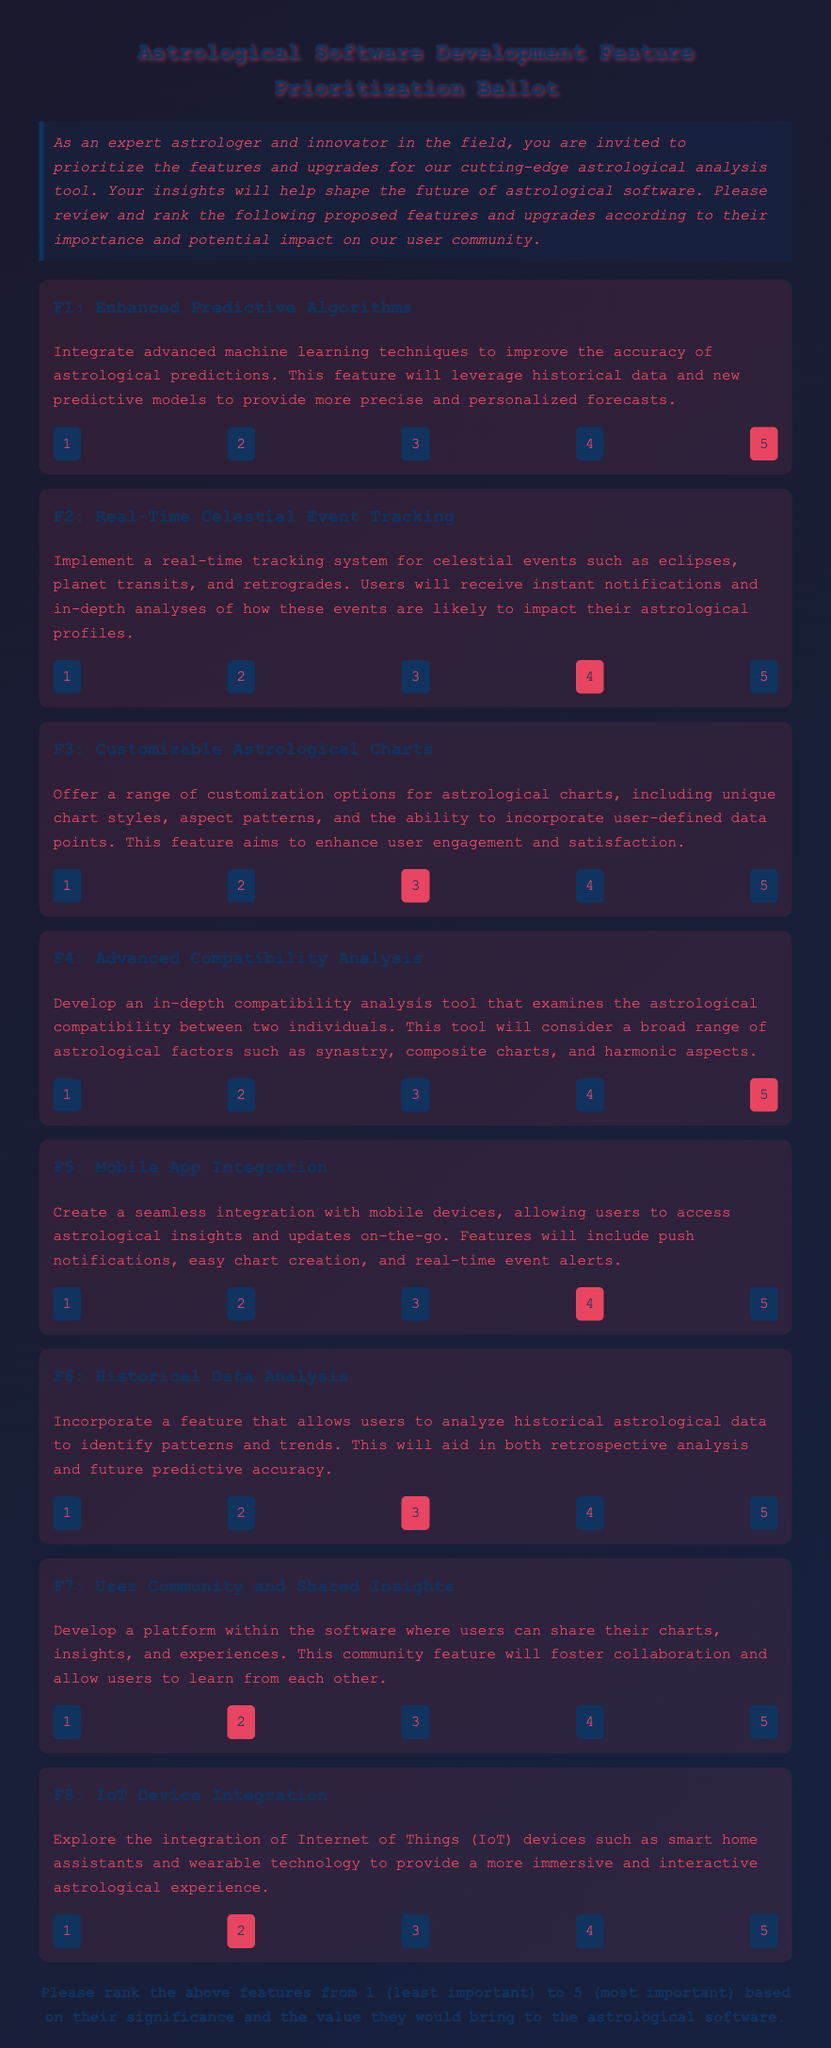What is the title of the document? The title of the document is prominently displayed at the top, indicating the purpose of the document.
Answer: Astrological Software Development Feature Prioritization Ballot What feature allows for real-time notifications of celestial events? This feature is specifically mentioned under one of the proposals.
Answer: Real-Time Celestial Event Tracking How many features are proposed in the document? The number of distinct features listed in the document can be counted.
Answer: Eight What is the proposed importance ranking for Mobile App Integration? The importance ranking is indicated by a checked radio button next to it.
Answer: Four Which feature focuses on User Community and Shared Insights? This feature is specifically named within its own section in the document.
Answer: User Community and Shared Insights What is the primary purpose of the Enhanced Predictive Algorithms feature? The purpose of this feature is directly mentioned in its description.
Answer: Improve the accuracy of astrological predictions How does the document suggest customizing astrological charts? This enhancement is outlined in its respective section.
Answer: Customizable Astrological Charts What is the ranking assigned by the user to Advanced Compatibility Analysis? The user's ranking can be identified through the checked option in that section.
Answer: Five 